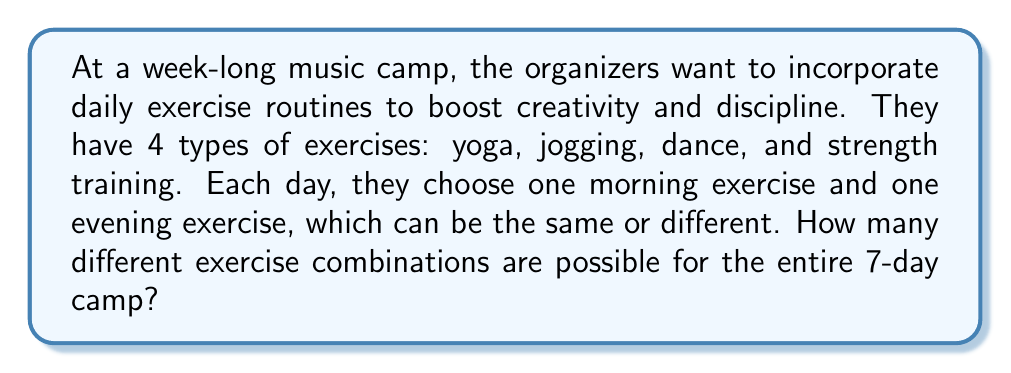Could you help me with this problem? Let's approach this step-by-step:

1) For each day, we need to choose two exercises: one for the morning and one for the evening.

2) For each of these choices, we have 4 options (yoga, jogging, dance, and strength training).

3) The number of ways to choose the morning exercise is 4, and the same for the evening exercise.

4) Therefore, for each day, we have $4 \times 4 = 16$ possible combinations.

5) Now, we need to make this choice for 7 days, and the choices for each day are independent of the other days.

6) When we have independent events, we multiply the number of possibilities for each event.

7) So, we need to calculate $16^7$, which represents the number of ways to choose 16 possibilities for each of the 7 days.

8) $16^7 = 2^{28} = 268,435,456$

Therefore, there are 268,435,456 different possible exercise routines for the entire week-long camp.
Answer: $268,435,456$ 